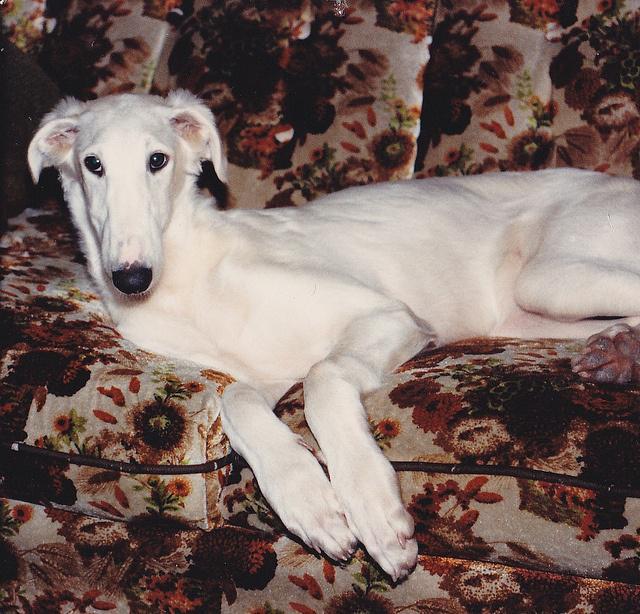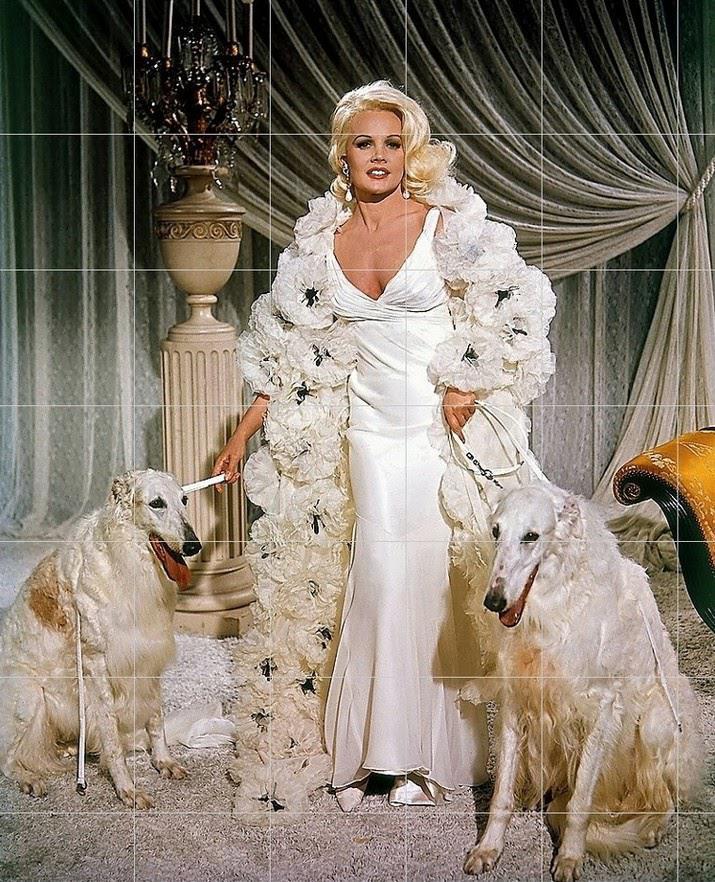The first image is the image on the left, the second image is the image on the right. Given the left and right images, does the statement "The right image contains exactly two dogs." hold true? Answer yes or no. Yes. The first image is the image on the left, the second image is the image on the right. Considering the images on both sides, is "A woman is holding a single dog on a leash." valid? Answer yes or no. No. 